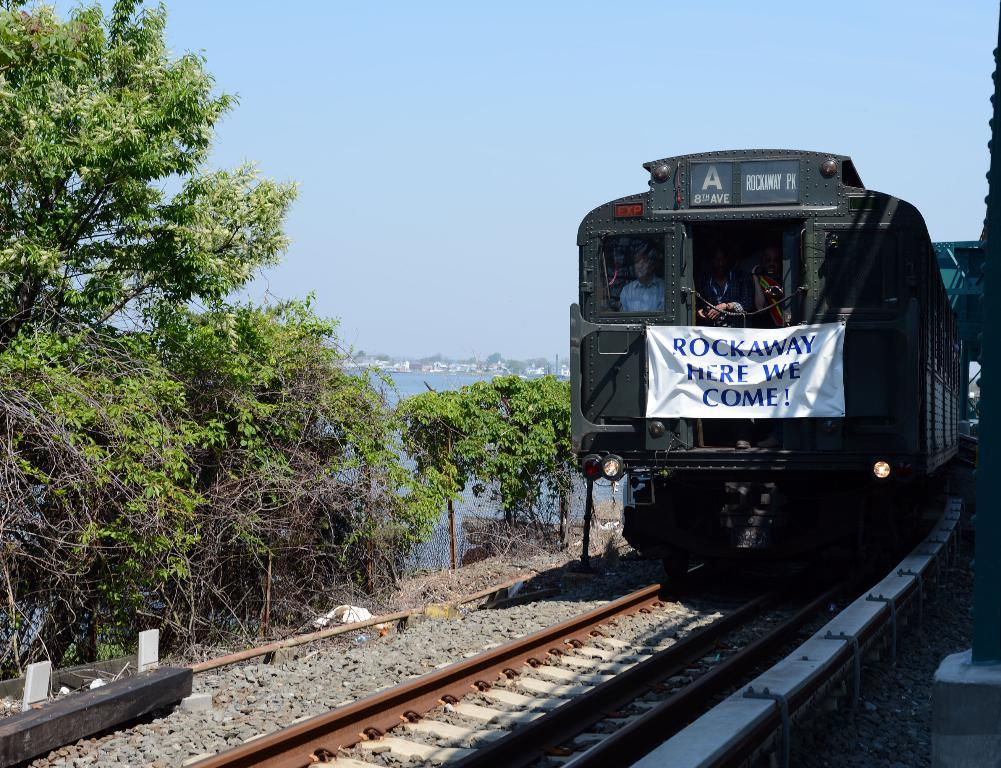<image>
Render a clear and concise summary of the photo. A black train car that says Rockaway here we come on the front. 